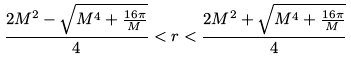Convert formula to latex. <formula><loc_0><loc_0><loc_500><loc_500>\frac { 2 M ^ { 2 } - \sqrt { M ^ { 4 } + \frac { 1 6 \pi } { M } } } { 4 } < r < \frac { 2 M ^ { 2 } + \sqrt { M ^ { 4 } + \frac { 1 6 \pi } { M } } } { 4 }</formula> 